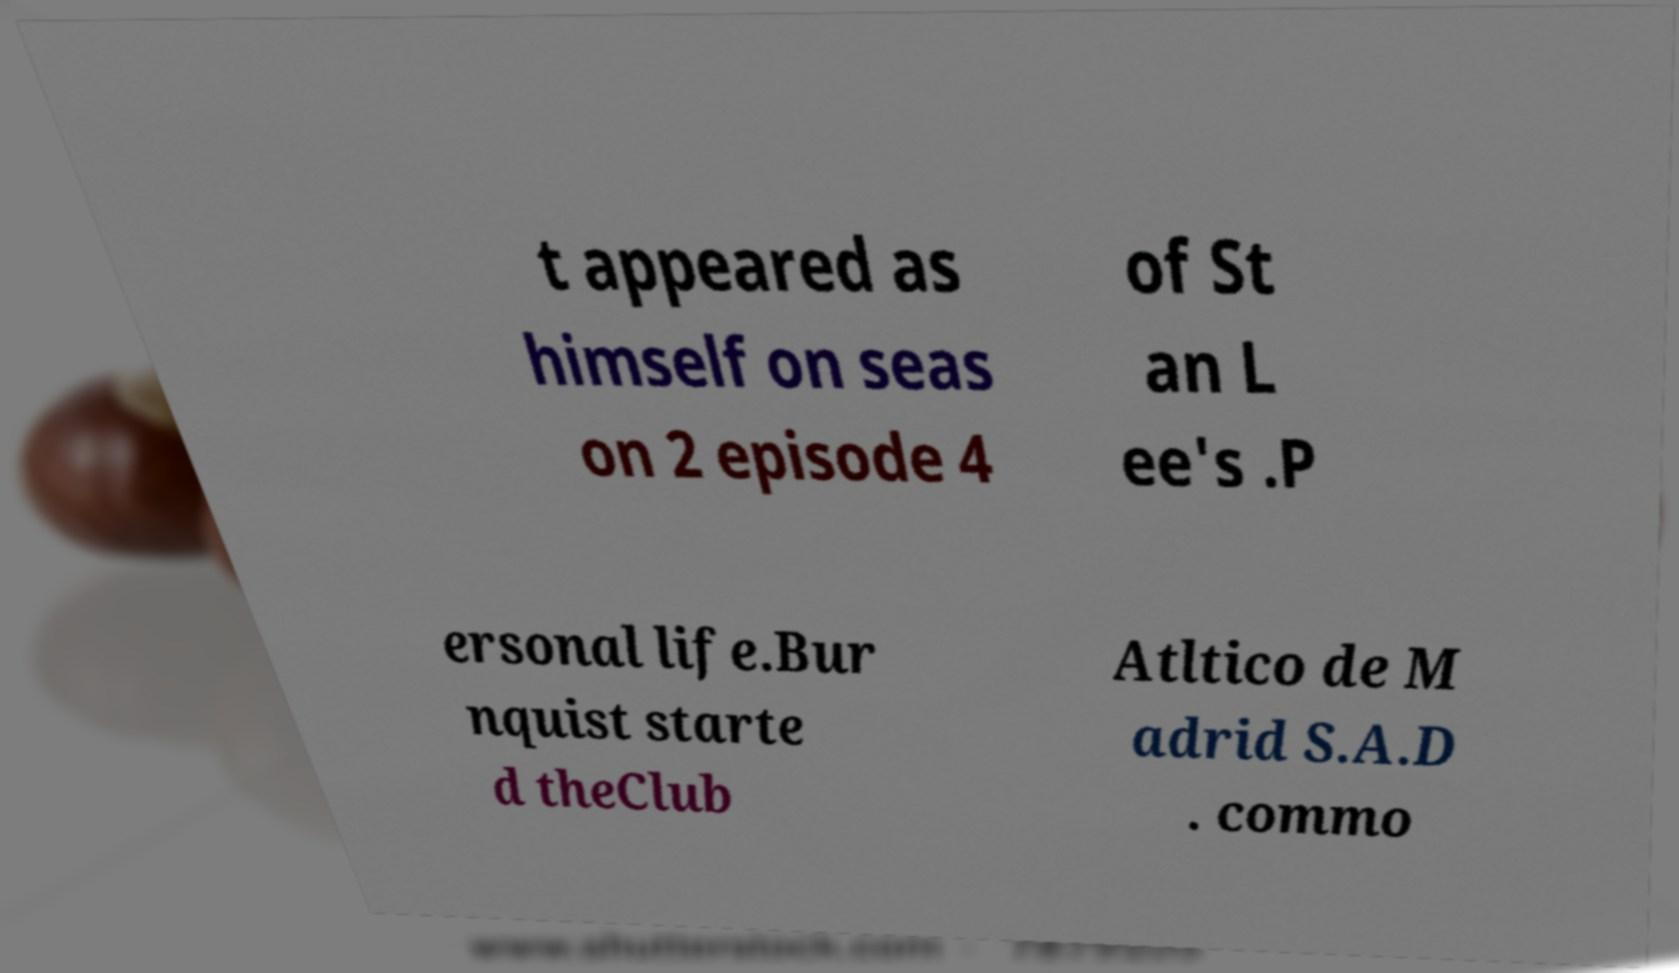Could you extract and type out the text from this image? t appeared as himself on seas on 2 episode 4 of St an L ee's .P ersonal life.Bur nquist starte d theClub Atltico de M adrid S.A.D . commo 